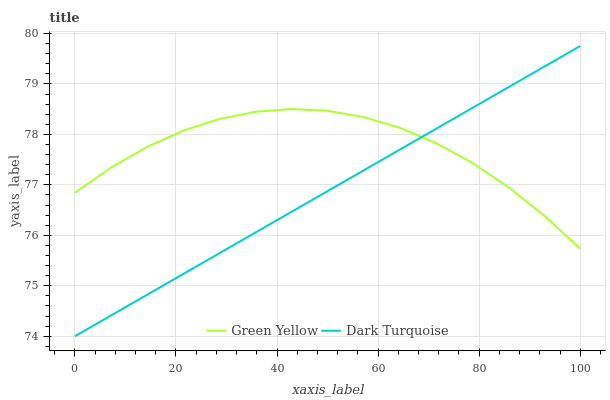Does Green Yellow have the minimum area under the curve?
Answer yes or no. No. Is Green Yellow the smoothest?
Answer yes or no. No. Does Green Yellow have the lowest value?
Answer yes or no. No. Does Green Yellow have the highest value?
Answer yes or no. No. 